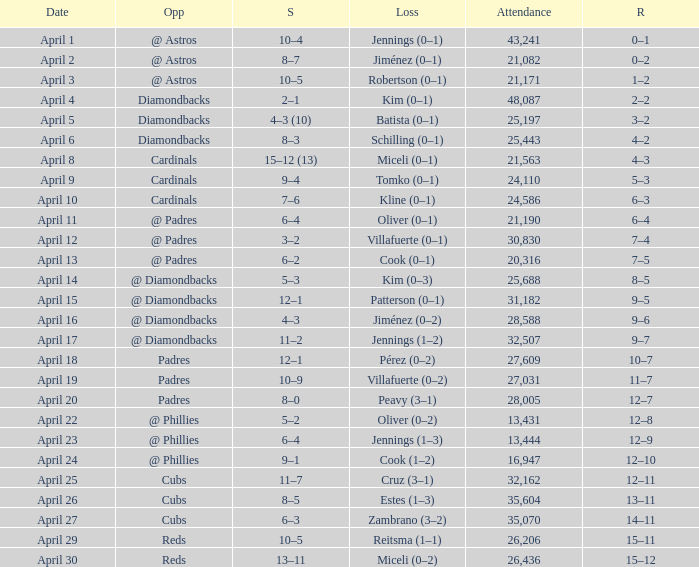What is the team's record on april 23? 12–9. 